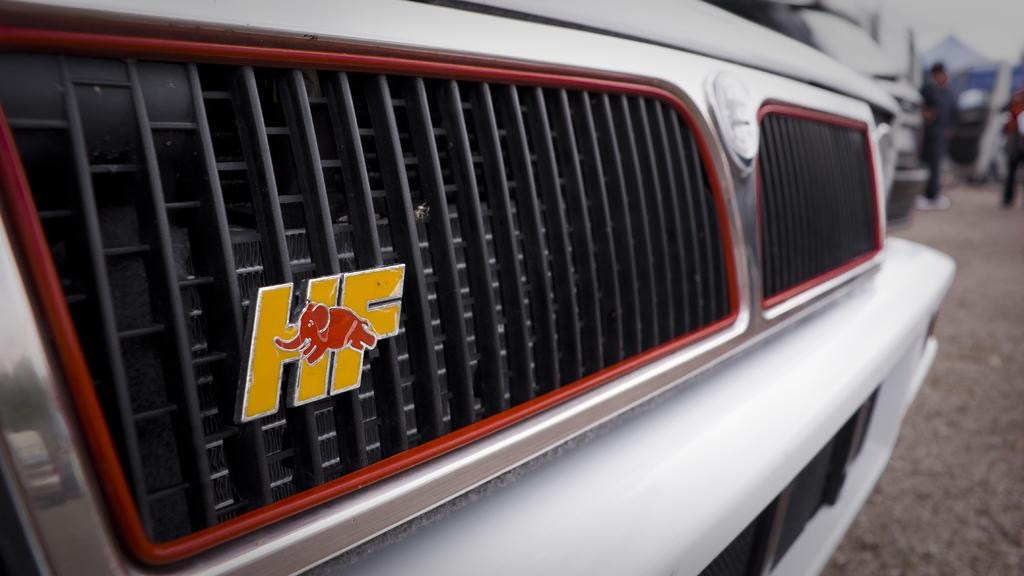What is the main subject in the foreground of the image? The bumper of a vehicle is in the foreground of the image. Can you describe the background of the image? There are two people in the background of the image, and the remaining objects are blurry. What type of trousers are the dogs wearing in the image? There are no dogs present in the image, so it is not possible to determine what type of trousers they might be wearing. 